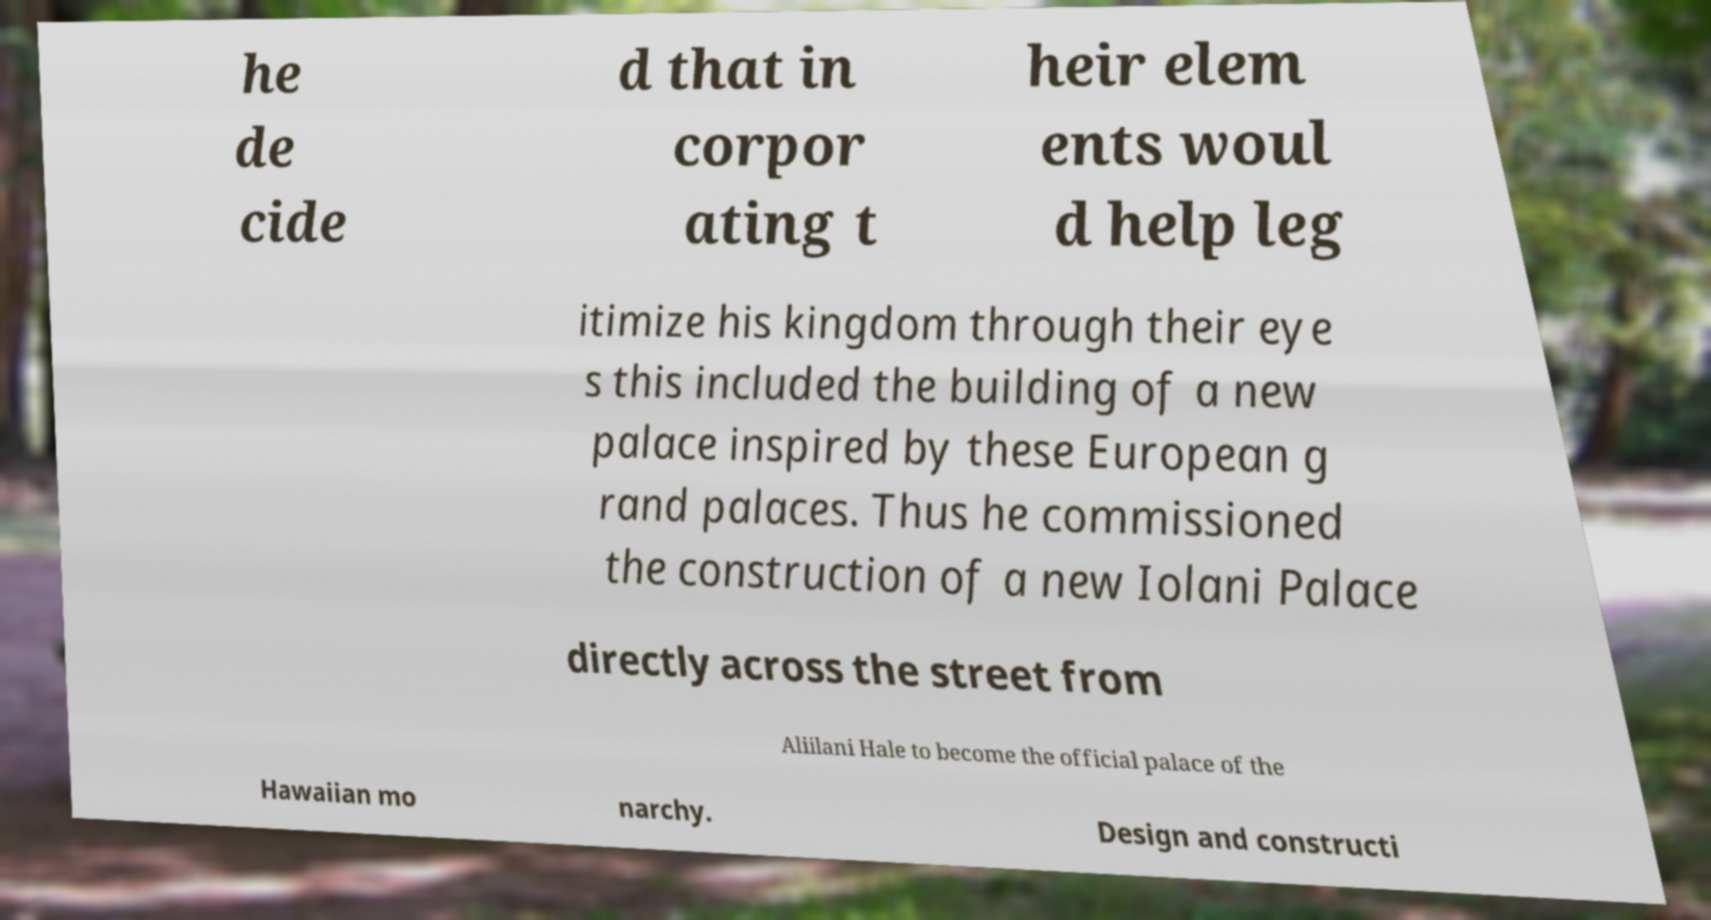There's text embedded in this image that I need extracted. Can you transcribe it verbatim? he de cide d that in corpor ating t heir elem ents woul d help leg itimize his kingdom through their eye s this included the building of a new palace inspired by these European g rand palaces. Thus he commissioned the construction of a new Iolani Palace directly across the street from Aliilani Hale to become the official palace of the Hawaiian mo narchy. Design and constructi 